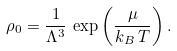Convert formula to latex. <formula><loc_0><loc_0><loc_500><loc_500>\rho _ { 0 } = \frac { 1 } { \Lambda ^ { 3 } } \, \exp { \left ( \frac { \mu } { k _ { B } \, T } \right ) } \, .</formula> 